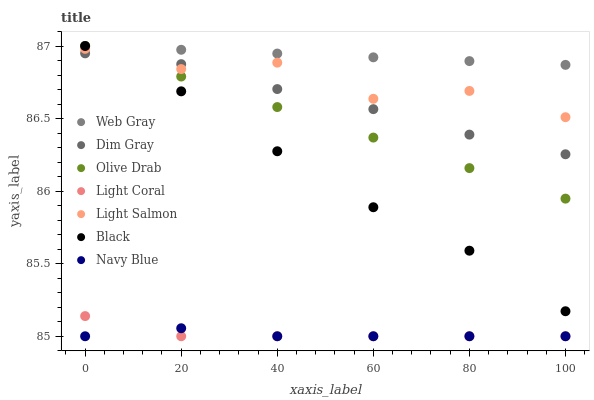Does Navy Blue have the minimum area under the curve?
Answer yes or no. Yes. Does Web Gray have the maximum area under the curve?
Answer yes or no. Yes. Does Dim Gray have the minimum area under the curve?
Answer yes or no. No. Does Dim Gray have the maximum area under the curve?
Answer yes or no. No. Is Web Gray the smoothest?
Answer yes or no. Yes. Is Light Salmon the roughest?
Answer yes or no. Yes. Is Dim Gray the smoothest?
Answer yes or no. No. Is Dim Gray the roughest?
Answer yes or no. No. Does Navy Blue have the lowest value?
Answer yes or no. Yes. Does Dim Gray have the lowest value?
Answer yes or no. No. Does Olive Drab have the highest value?
Answer yes or no. Yes. Does Dim Gray have the highest value?
Answer yes or no. No. Is Light Coral less than Black?
Answer yes or no. Yes. Is Light Salmon greater than Navy Blue?
Answer yes or no. Yes. Does Navy Blue intersect Light Coral?
Answer yes or no. Yes. Is Navy Blue less than Light Coral?
Answer yes or no. No. Is Navy Blue greater than Light Coral?
Answer yes or no. No. Does Light Coral intersect Black?
Answer yes or no. No. 